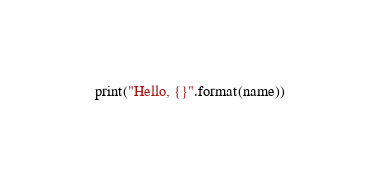Convert code to text. <code><loc_0><loc_0><loc_500><loc_500><_Python_>    print("Hello, {}".format(name))</code> 